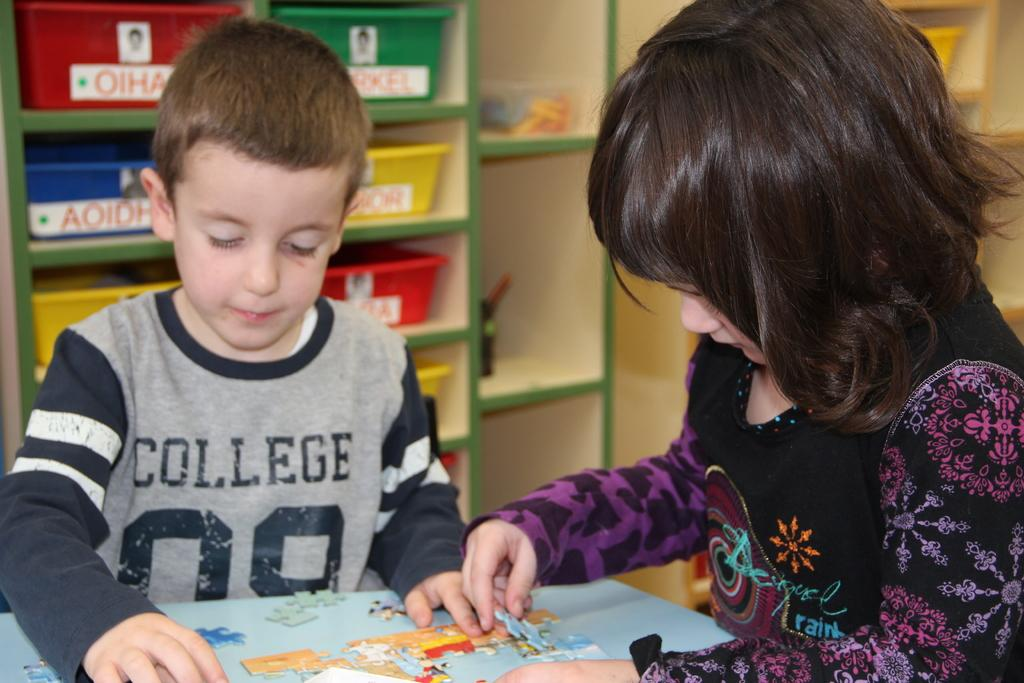What is the kid on the left side of the image doing? The kid on the left side of the image is trying to fix a puzzle. What is the girl on the right side of the image doing? The girl on the right side of the image is also trying to fix a puzzle. How many people are present in the image? There are two people in the image, a kid and a girl. What color is the shirt of the person crying in the image? There is no person crying in the image; both the kid and the girl are focused on fixing a puzzle. 